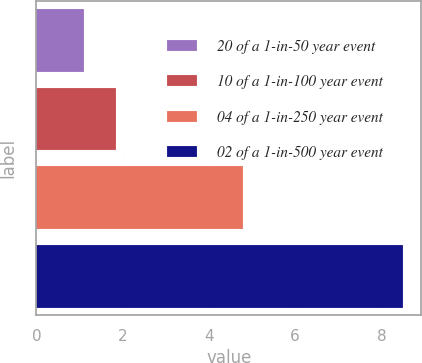Convert chart. <chart><loc_0><loc_0><loc_500><loc_500><bar_chart><fcel>20 of a 1-in-50 year event<fcel>10 of a 1-in-100 year event<fcel>04 of a 1-in-250 year event<fcel>02 of a 1-in-500 year event<nl><fcel>1.1<fcel>1.84<fcel>4.8<fcel>8.5<nl></chart> 